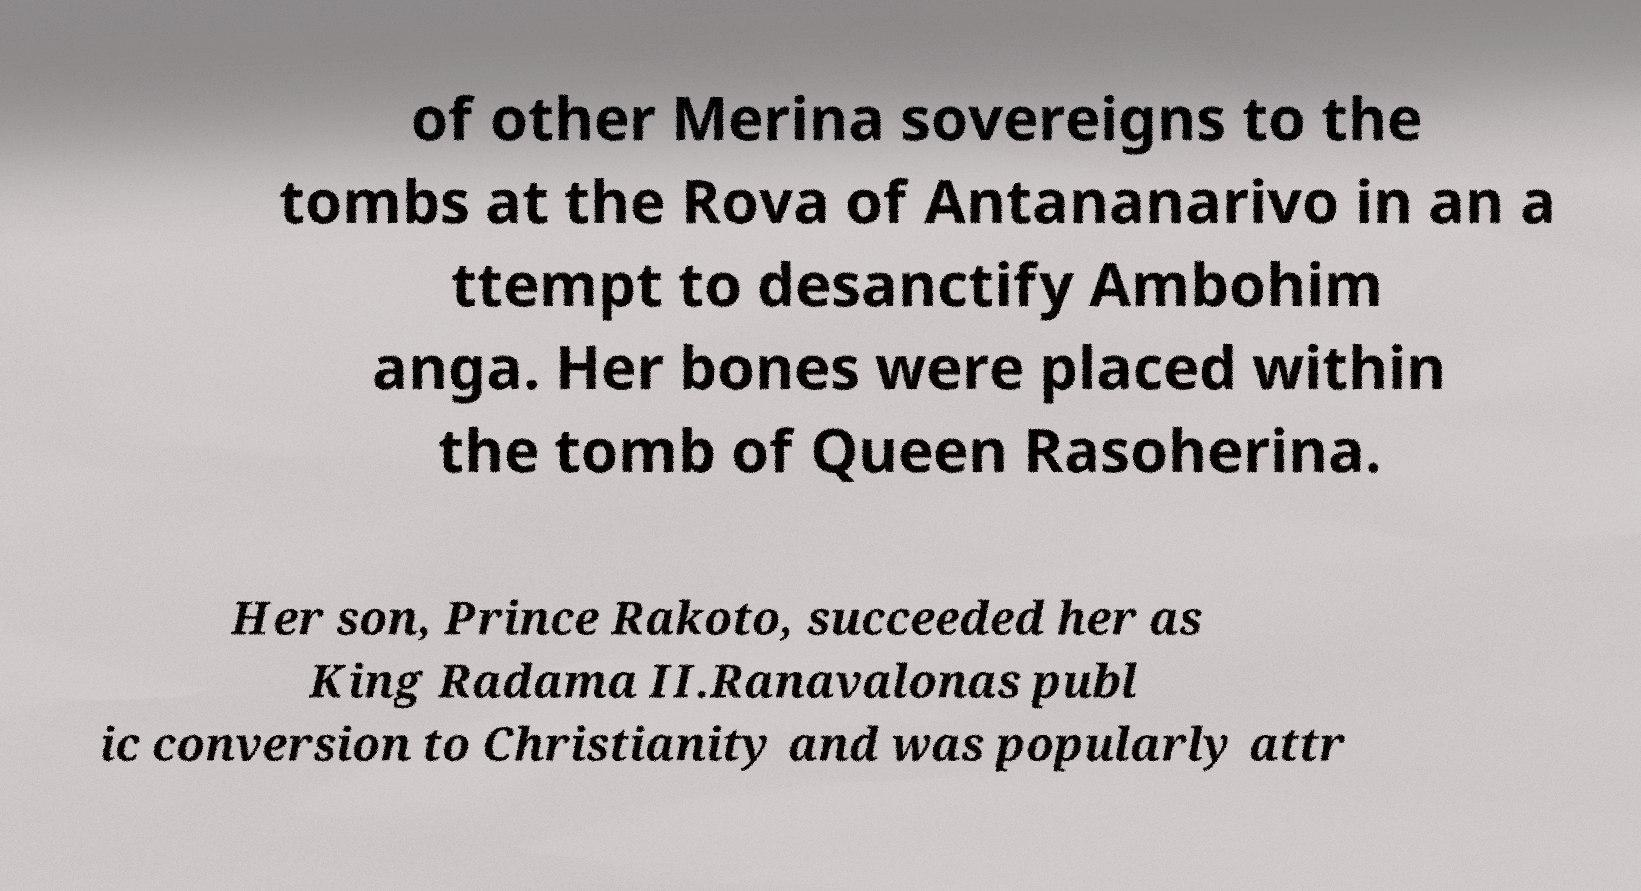Could you assist in decoding the text presented in this image and type it out clearly? of other Merina sovereigns to the tombs at the Rova of Antananarivo in an a ttempt to desanctify Ambohim anga. Her bones were placed within the tomb of Queen Rasoherina. Her son, Prince Rakoto, succeeded her as King Radama II.Ranavalonas publ ic conversion to Christianity and was popularly attr 